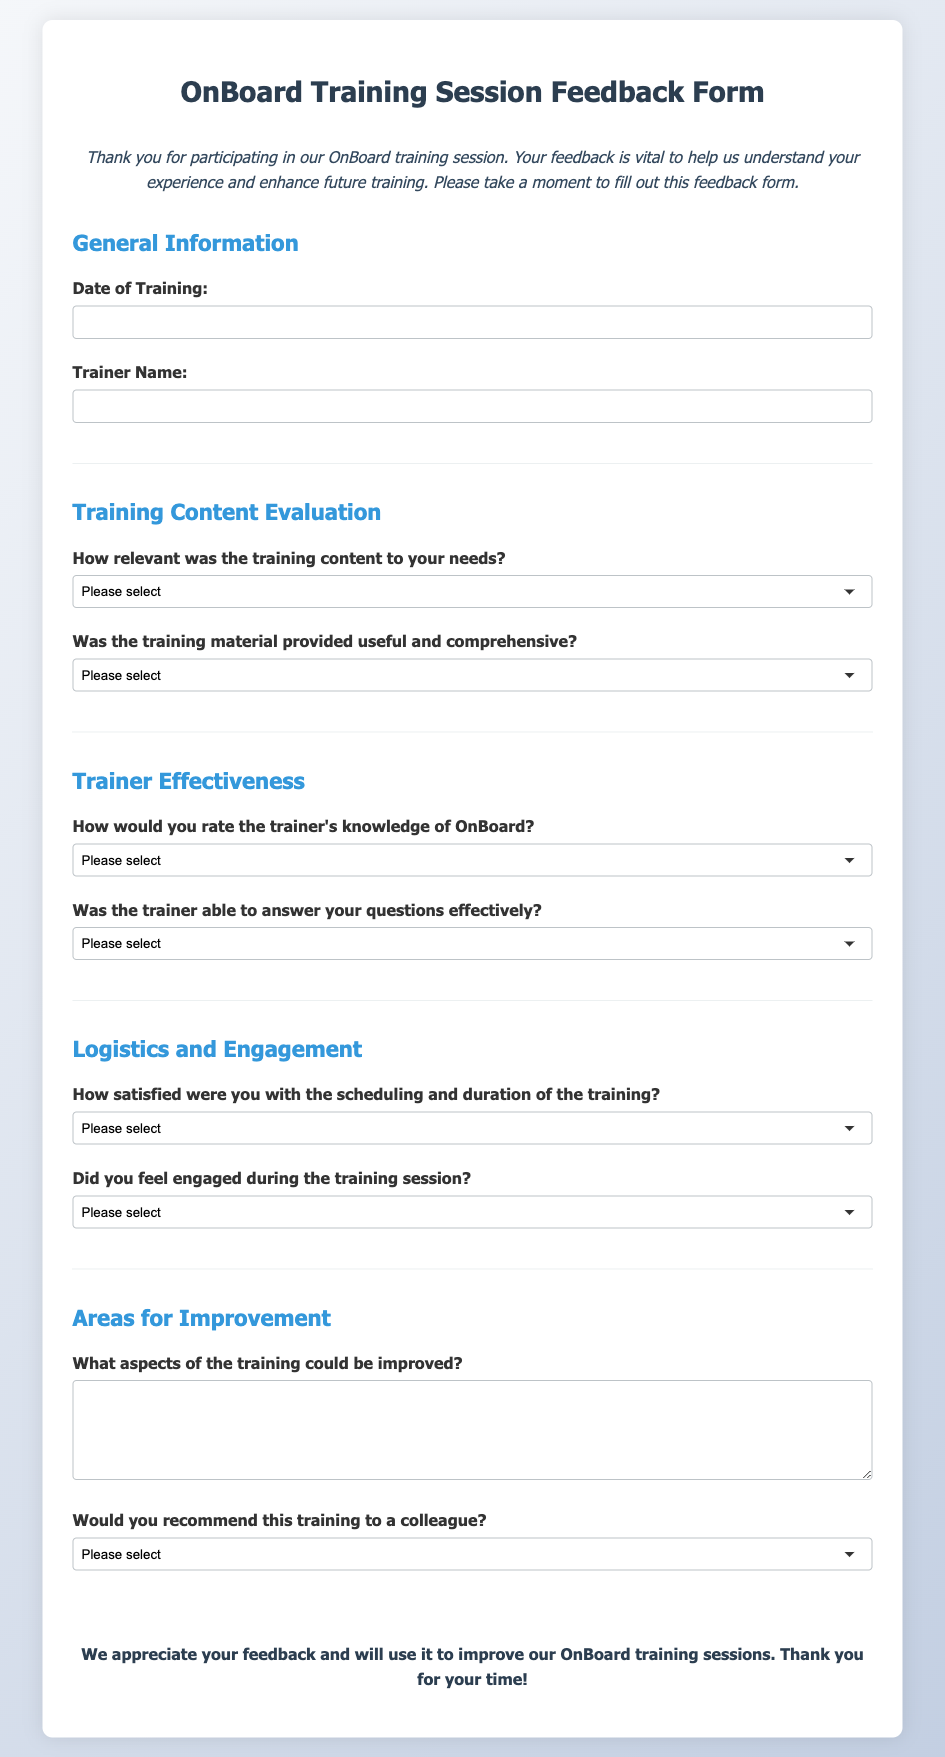What is the title of the document? The title is presented prominently in the header section of the document.
Answer: OnBoard Training Session Feedback Form What is the main purpose of this feedback form? The purpose is mentioned in the introductory paragraph, indicating the intention to gather feedback for improvement.
Answer: To evaluate client satisfaction and enhance future training What is the first piece of information the form asks for? The form requests general information, starting with the date of the training session.
Answer: Date of Training How satisfied were participants with the scheduling of the training? This rating is assessed through a specific question regarding scheduling satisfaction.
Answer: 1 to 5 (very unsatisfied to very satisfied) What is one area for improvement participants are asked to provide feedback on? The form includes a section specifically dedicated to identifying areas for improvement in training, asking for specific suggestions.
Answer: Aspects of the training could be improved How does the feedback form evaluate the trainer's effectiveness? The evaluation of the trainer's effectiveness is assessed through specific rating questions regarding knowledge and question-answering capability.
Answer: Through ratings on knowledge and question answering Would participants recommend this training to a colleague? This is specifically queried towards the end of the feedback form.
Answer: Yes, No, Maybe What is the color of the text in the introduction? The text color of the introduction is specified within the style section of the HTML document.
Answer: Dark gray What is the style type used for the document's body text? The style type is indicated in the CSS section, describing the font used for the document.
Answer: Segoe UI, Tahoma, Geneva, Verdana, sans-serif 